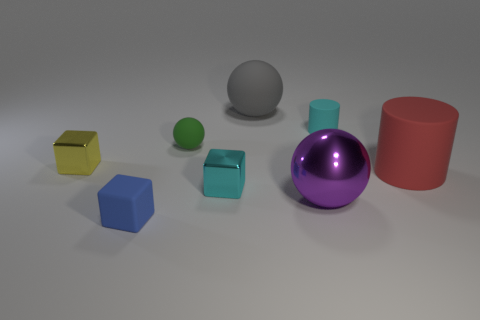Is there a cyan thing made of the same material as the big cylinder?
Provide a short and direct response. Yes. What number of large red objects have the same shape as the small green thing?
Give a very brief answer. 0. What is the shape of the small cyan object to the left of the rubber cylinder that is behind the metal object to the left of the tiny blue matte object?
Offer a terse response. Cube. There is a large object that is to the left of the small cyan cylinder and right of the gray thing; what is its material?
Your answer should be very brief. Metal. Do the object that is right of the cyan cylinder and the small cyan cylinder have the same size?
Make the answer very short. No. Is there any other thing that has the same size as the cyan cylinder?
Your answer should be compact. Yes. Is the number of small matte things that are behind the purple object greater than the number of cyan matte cylinders in front of the small green ball?
Keep it short and to the point. Yes. There is a large ball in front of the small metal object that is in front of the cylinder in front of the tiny cylinder; what is its color?
Your answer should be compact. Purple. There is a tiny metallic cube that is in front of the large red cylinder; does it have the same color as the big cylinder?
Keep it short and to the point. No. What number of other things are the same color as the metal sphere?
Provide a succinct answer. 0. 